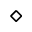Convert formula to latex. <formula><loc_0><loc_0><loc_500><loc_500>\diamond</formula> 